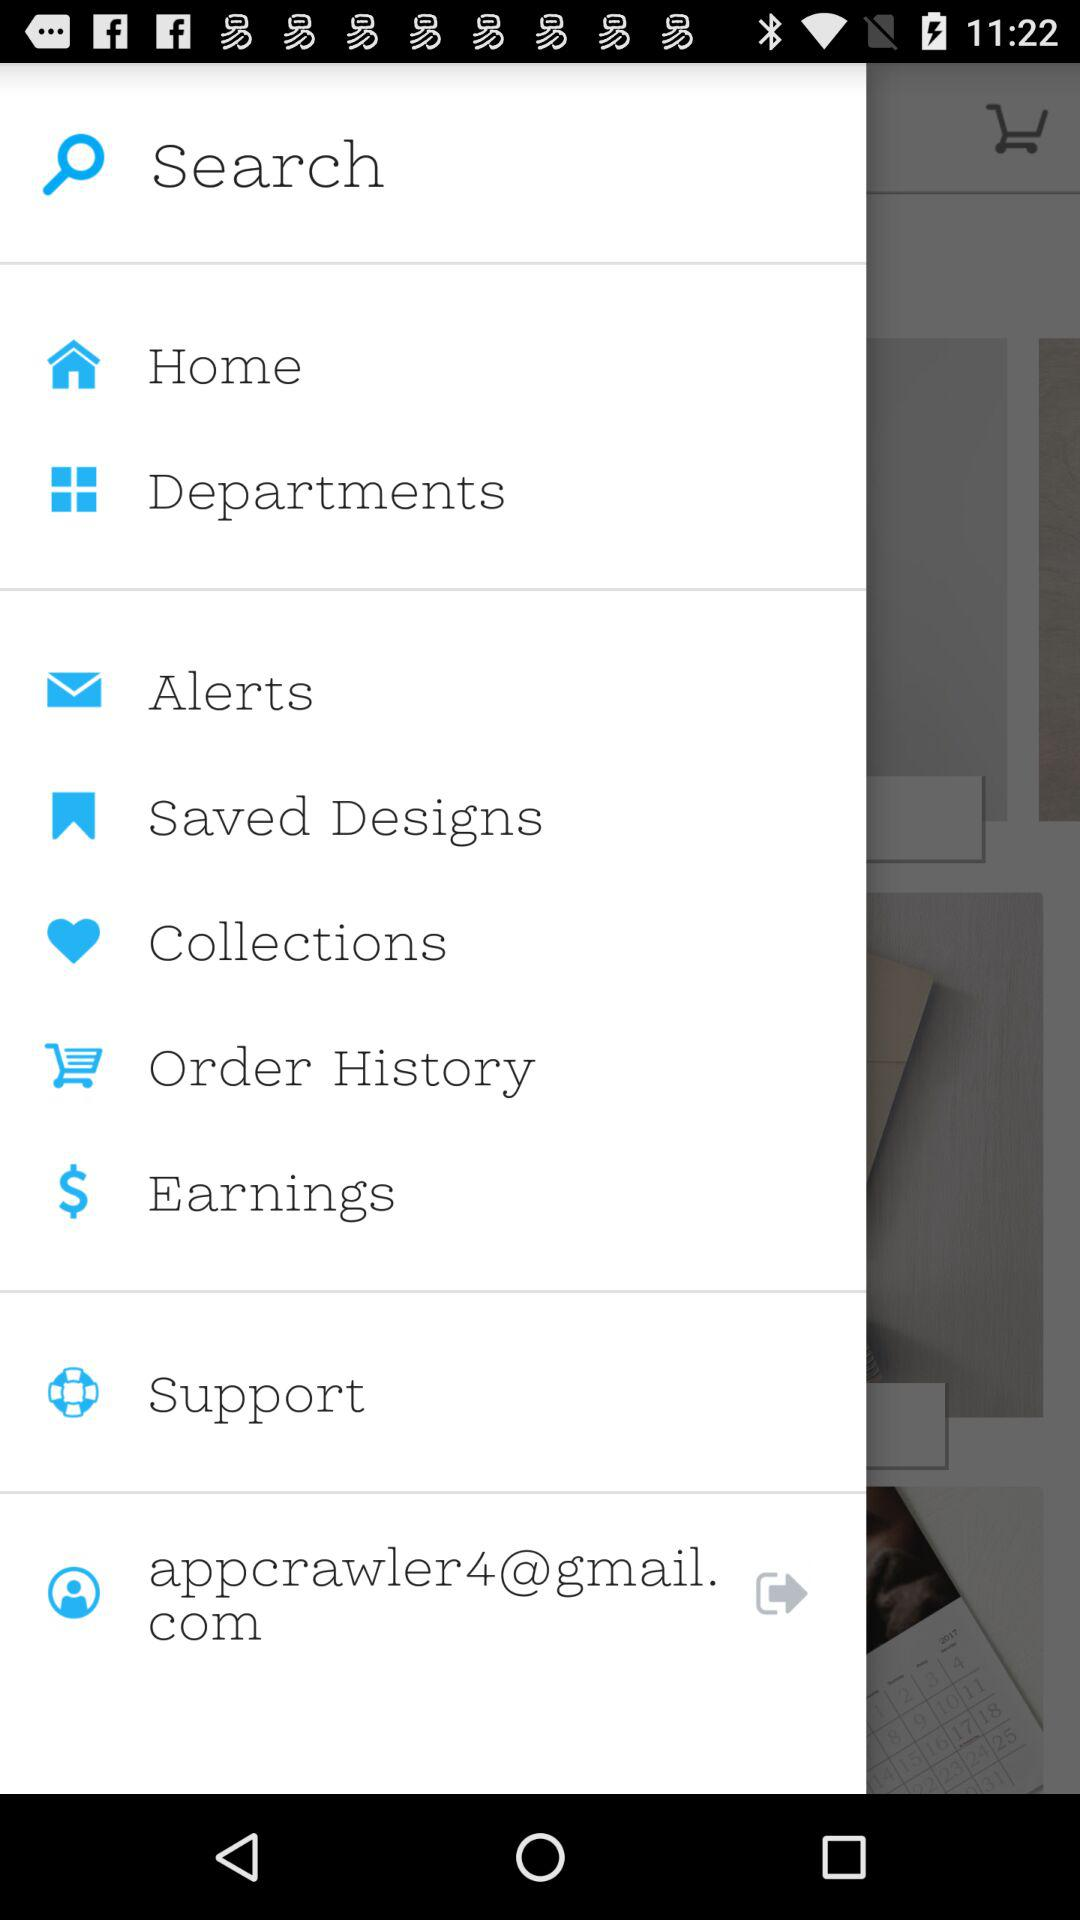What is the user's Gmail account? The user's Gmail account is appcrawler4@gmail.com. 